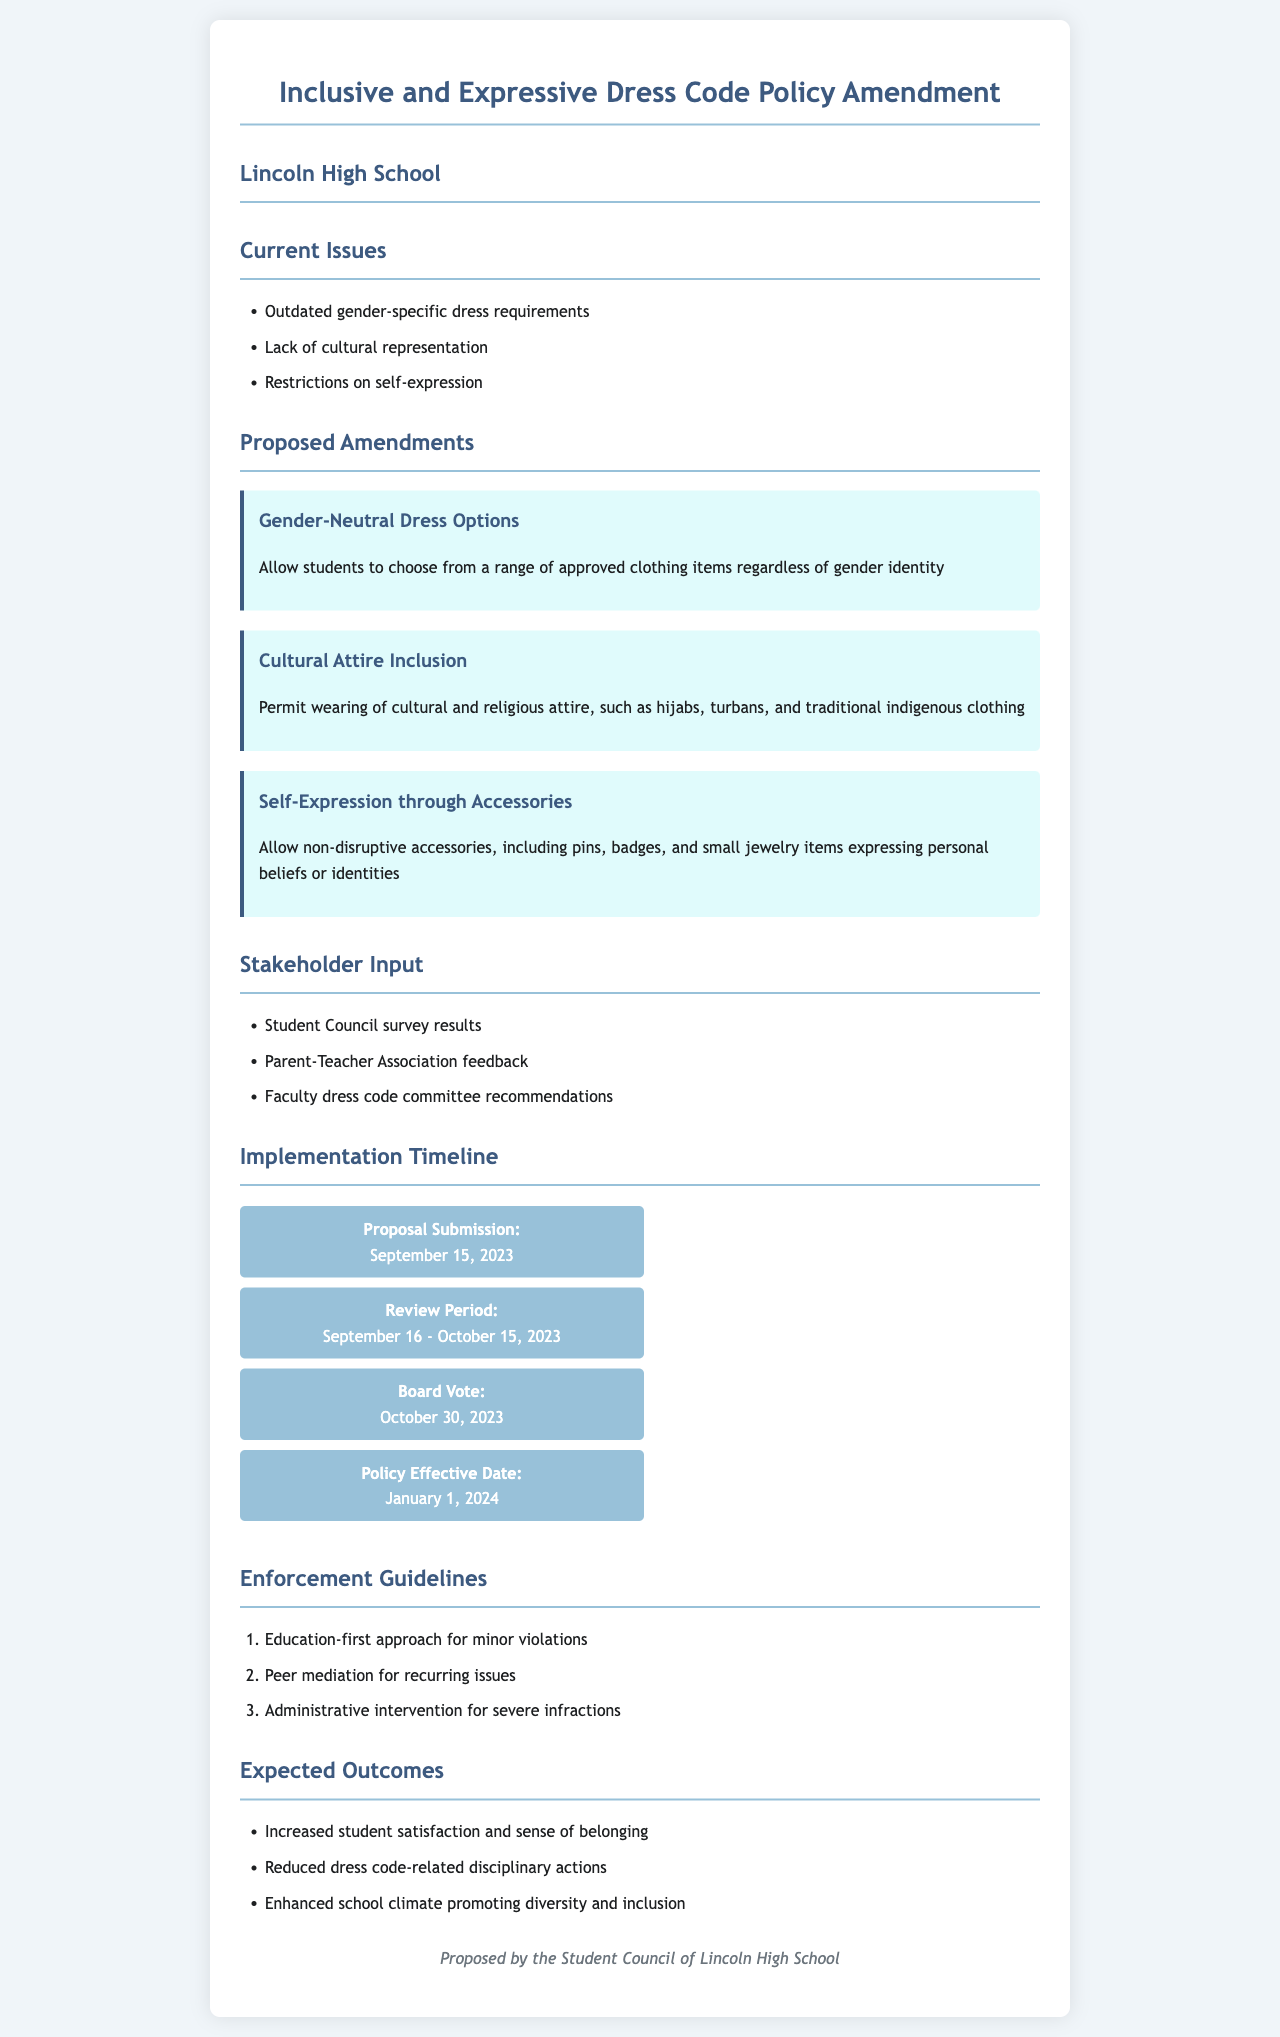What are the current issues with the dress code? The current issues are listed under the "Current Issues" section of the document, which includes outdated gender-specific dress requirements, lack of cultural representation, and restrictions on self-expression.
Answer: Outdated gender-specific dress requirements, lack of cultural representation, restrictions on self-expression What is one proposed amendment for dress code inclusivity? The document provides a section titled "Proposed Amendments" that details multiple amendments, including Gender-Neutral Dress Options.
Answer: Gender-Neutral Dress Options When is the Board Vote scheduled? The implementation timeline includes specific dates for events, with the Board Vote date clearly stated.
Answer: October 30, 2023 What is expected as an outcome of the proposed amendments? The document outlines several expected outcomes under the "Expected Outcomes" section, including increased student satisfaction and enhanced school climate promoting diversity and inclusion.
Answer: Increased student satisfaction and sense of belonging What approach is suggested for minor violations? The "Enforcement Guidelines" section of the document indicates a specific approach to handle violations of the dress code, particularly for minor issues.
Answer: Education-first approach 